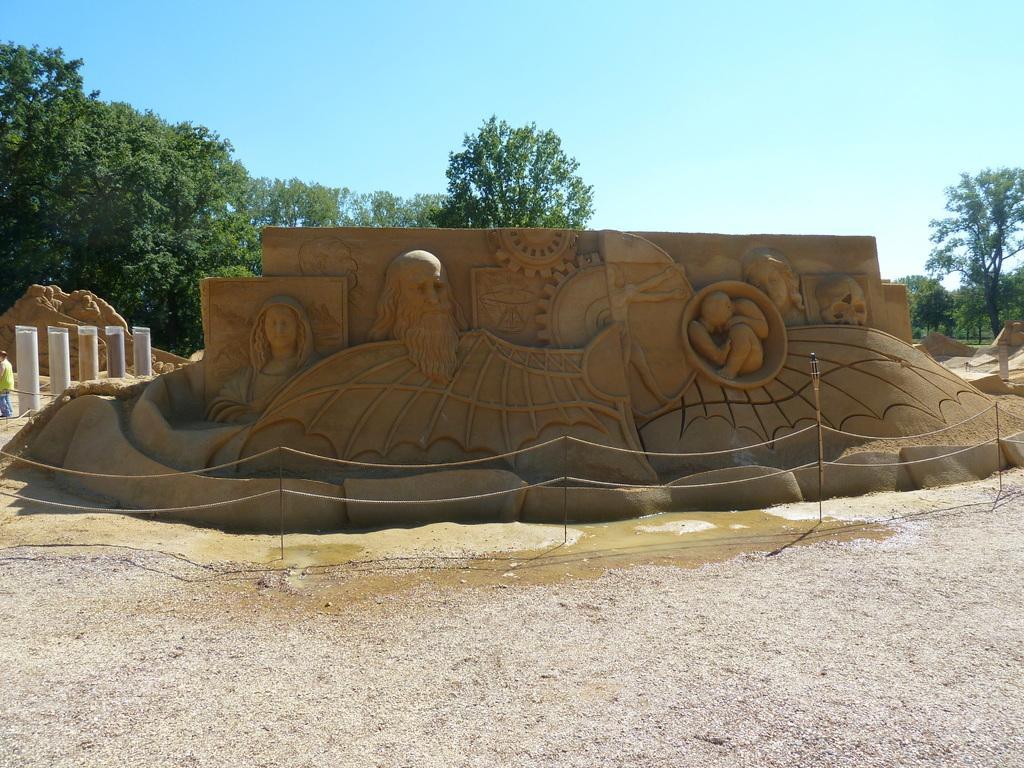Describe this image in one or two sentences. At the center of the image there is a sand sculpture. In the background there are trees and sky. 